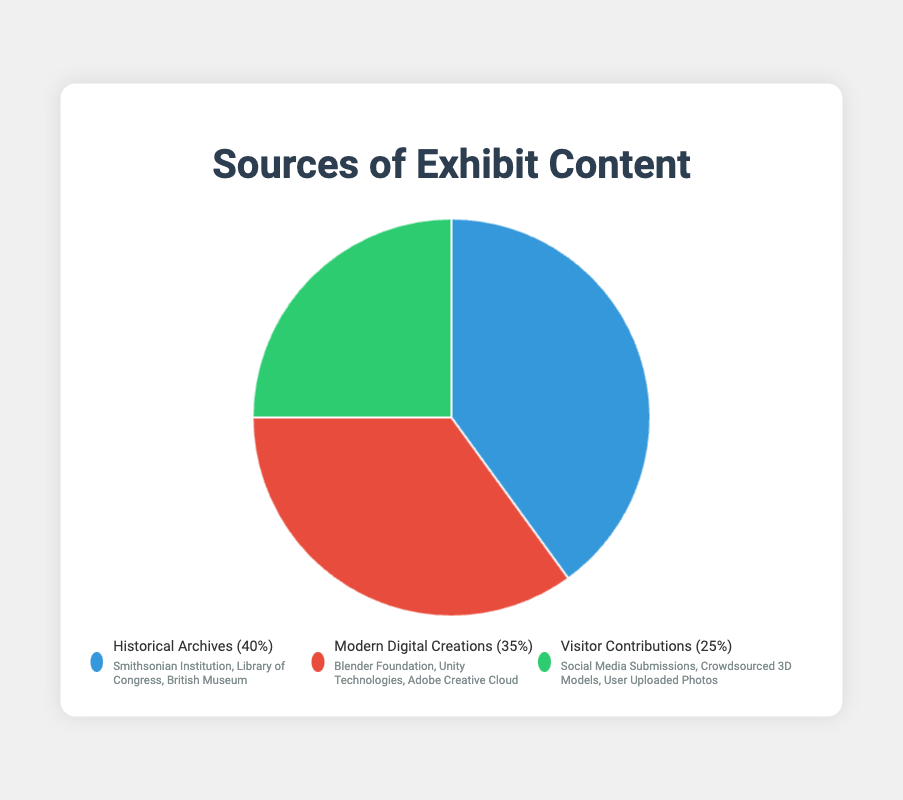Which source contributes the most content to the exhibit? The pie chart shows the percentage contributions of the three sources. Historical Archives contributes 40%, which is the largest percentage among the three.
Answer: Historical Archives How much more does Historical Archives contribute compared to Visitor Contributions? Historical Archives contributes 40%, and Visitor Contributions contribute 25%. The difference is calculated by subtracting 25 from 40. 40% - 25% = 15%.
Answer: 15% What is the combined contribution percentage of Historical Archives and Modern Digital Creations? Historical Archives contributes 40% and Modern Digital Creations contribute 35%. Adding these together: 40% + 35% = 75%.
Answer: 75% Which source has the smallest contribution to the exhibit's content? The pie chart indicates the contributions of all three sources. Visitor Contributions, at 25%, are the smallest.
Answer: Visitor Contributions By what percentage does Modern Digital Creations' contribution exceed Visitor Contributions? Modern Digital Creations contribute 35%, and Visitor Contributions contribute 25%. The difference is 35% - 25% = 10%.
Answer: 10% What color is used to represent Historical Archives? The legend and sections of the pie chart visually indicate the colors assigned to each category. Historical Archives is represented by blue.
Answer: Blue Which sources, when combined, account for 60% of the exhibit's content? Visitor Contributions account for 25% and Modern Digital Creations account for 35%. Adding these two percentages: 25% + 35% = 60%.
Answer: Modern Digital Creations and Visitor Contributions If Visitor Contributions increased by 10%, what would its new percentage be and how would it compare to the percentage of Modern Digital Creations? Increasing Visitor Contributions by 10% would yield 25% + 10% = 35%. This new percentage is now equal to the percentage of Modern Digital Creations, which is 35%.
Answer: Both would be 35% Which sources are represented by red and green colors? Examining the legend and pie chart, Modern Digital Creations are represented by red, and Visitor Contributions are represented by green.
Answer: Modern Digital Creations (red) and Visitor Contributions (green) 